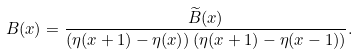<formula> <loc_0><loc_0><loc_500><loc_500>B ( x ) = \frac { \widetilde { B } ( x ) } { \left ( \eta ( x + 1 ) - \eta ( x ) \right ) \left ( \eta ( x + 1 ) - \eta ( x - 1 ) \right ) } .</formula> 